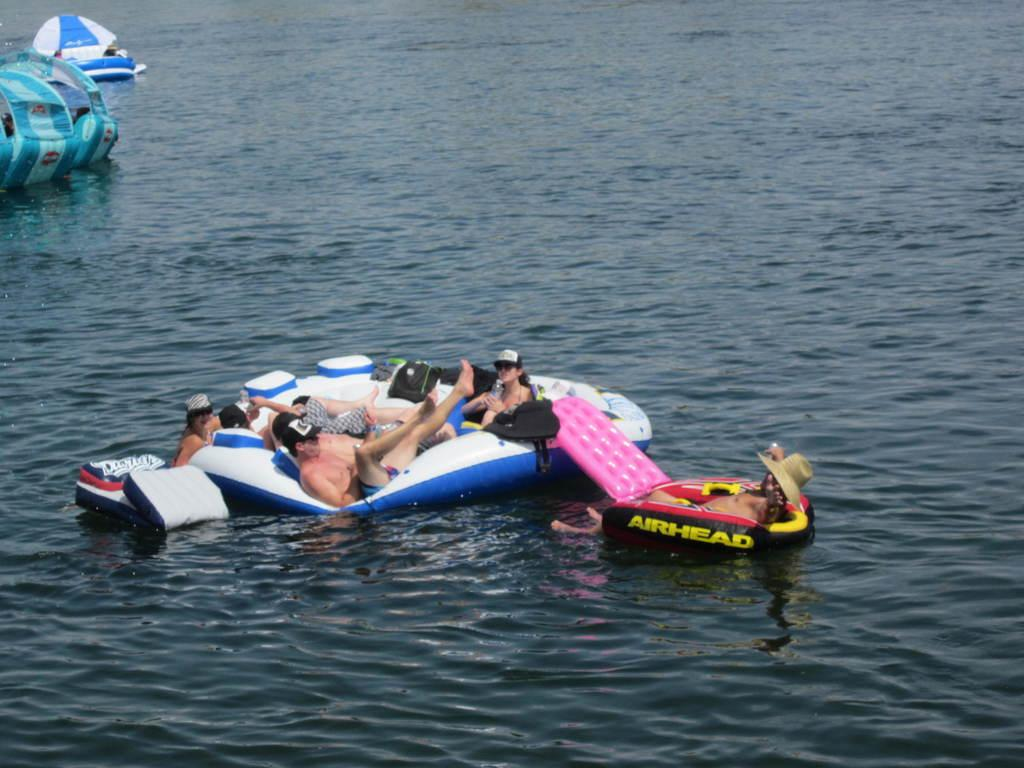<image>
Summarize the visual content of the image. People in the water on floats, one of which is an Airhead brand. 